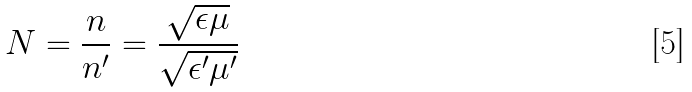Convert formula to latex. <formula><loc_0><loc_0><loc_500><loc_500>N = \frac { n } { n ^ { \prime } } = \frac { \sqrt { \epsilon \mu } } { \sqrt { \epsilon ^ { \prime } \mu ^ { \prime } } }</formula> 